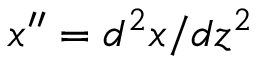<formula> <loc_0><loc_0><loc_500><loc_500>x ^ { \prime \prime } = d ^ { 2 } x / d z ^ { 2 }</formula> 